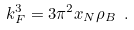Convert formula to latex. <formula><loc_0><loc_0><loc_500><loc_500>k _ { F } ^ { 3 } = 3 \pi ^ { 2 } x _ { N } \rho _ { B } \ .</formula> 